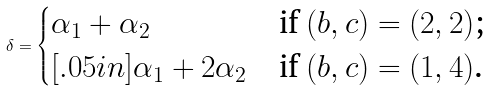Convert formula to latex. <formula><loc_0><loc_0><loc_500><loc_500>\delta = \begin{cases} \alpha _ { 1 } + \alpha _ { 2 } & \text {if $(b,c) = (2,2)$;} \\ [ . 0 5 i n ] \alpha _ { 1 } + 2 \alpha _ { 2 } & \text {if $(b,c) = (1,4)$.} \end{cases}</formula> 